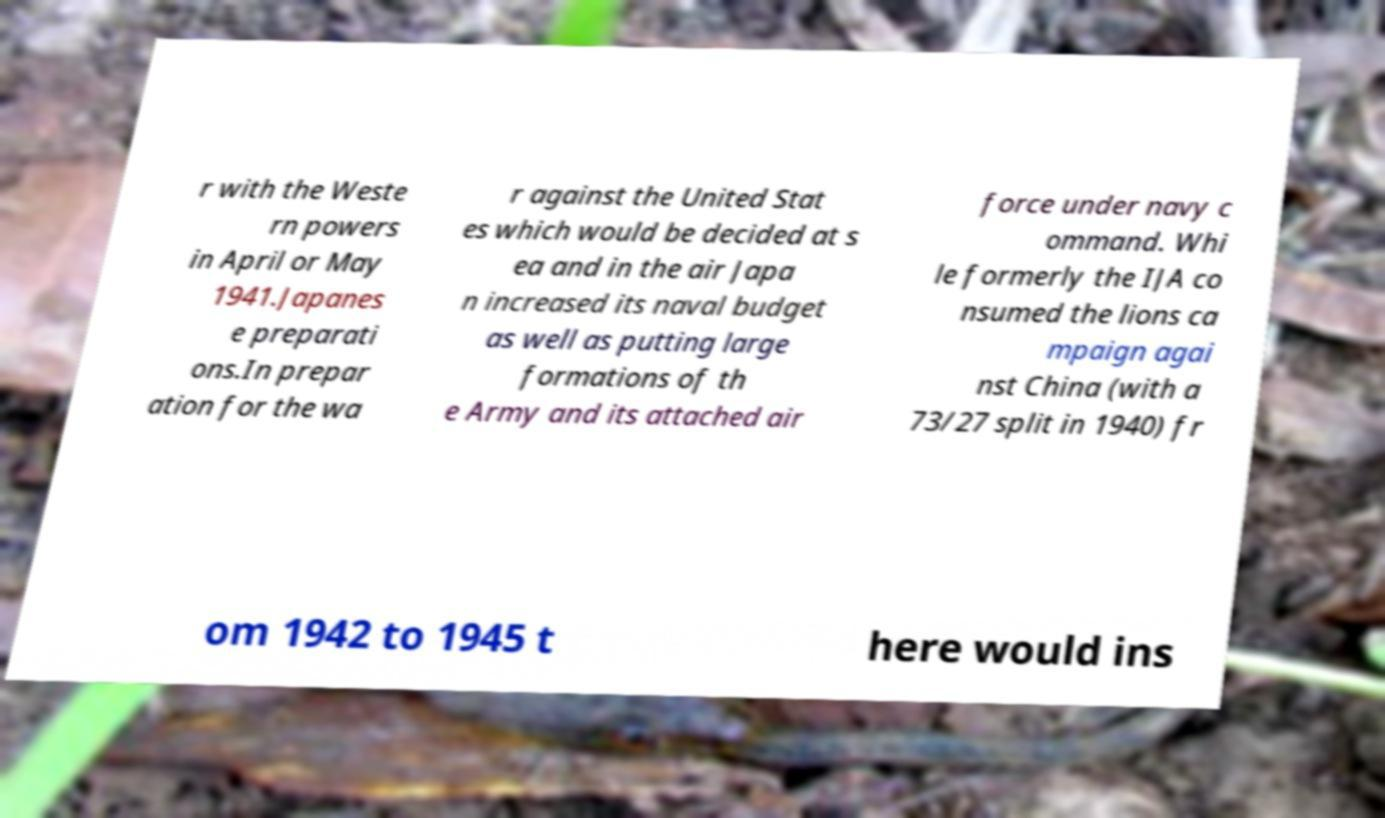For documentation purposes, I need the text within this image transcribed. Could you provide that? r with the Weste rn powers in April or May 1941.Japanes e preparati ons.In prepar ation for the wa r against the United Stat es which would be decided at s ea and in the air Japa n increased its naval budget as well as putting large formations of th e Army and its attached air force under navy c ommand. Whi le formerly the IJA co nsumed the lions ca mpaign agai nst China (with a 73/27 split in 1940) fr om 1942 to 1945 t here would ins 